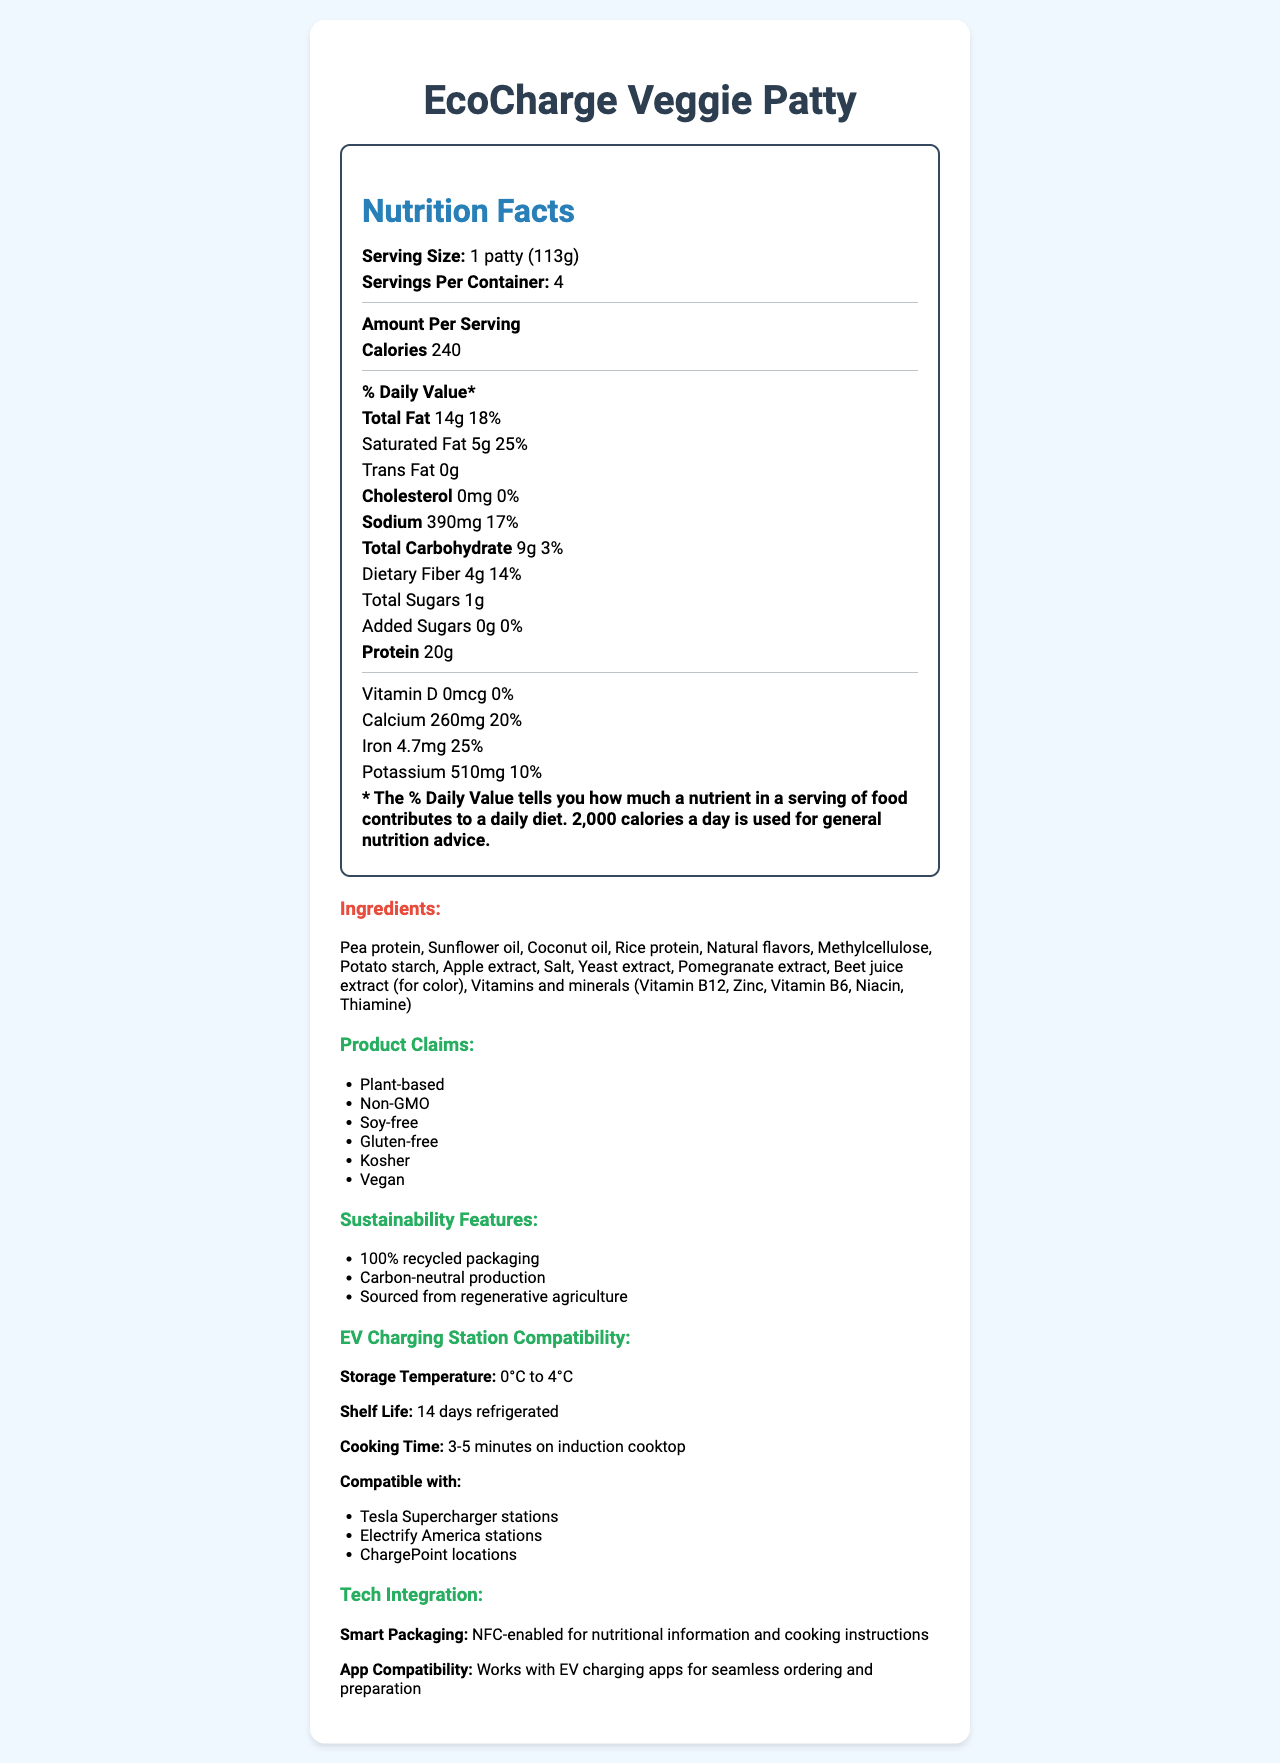what is the serving size? The document specifies the serving size under the "Nutrition Facts" section.
Answer: 1 patty (113g) how many calories are in one serving? The calories per serving are prominently displayed in the "Nutrition Facts" section.
Answer: 240 how many servings are in each container? The "Nutrition Facts" section lists "Servings Per Container" as 4.
Answer: 4 what is the amount of protein per serving? The amount of protein is clearly mentioned under the "Nutrition Facts" section.
Answer: 20g which claims are associated with this product? The claims are listed under the "Product Claims" section.
Answer: Plant-based, Non-GMO, Soy-free, Gluten-free, Kosher, Vegan the product contains which type of dietary fiber? A. Soluble B. Insoluble C. Both soluble and insoluble The type of dietary fiber is not specified in the document.
Answer: Cannot be determined how much sodium is in each serving, and what is the % daily value (%DV)? The "Nutrition Facts" section shows the sodium amount and %DV.
Answer: 390mg, 17% are there any added sugars in the product? The document lists "Added Sugars" as 0g and 0% daily value.
Answer: No is the product gluten-free? The product is listed as Gluten-free under the "Product Claims" section.
Answer: Yes what sustainability features does this product have? The sustainability features are listed in the "Sustainability Features" section.
Answer: 100% recycled packaging, Carbon-neutral production, Sourced from regenerative agriculture what is the storage temperature for the product at EV charging stations? The storage temperature is stated under the "EV Charging Station Compatibility" section.
Answer: 0°C to 4°C what are the main ingredients of the EcoCharge Veggie Patty? The ingredients are listed under the "Ingredients" section.
Answer: Pea protein, Sunflower oil, Coconut oil, Rice protein, Natural flavors, Methylcellulose, Potato starch, Apple extract, Salt, Yeast extract, Pomegranate extract, Beet juice extract, Vitamins and minerals which stations are compatible with this product? A. Tesla Supercharger stations B. Electrify America stations C. ChargePoint locations D. All of the above The document states compatibility with Tesla Supercharger stations, Electrify America stations, and ChargePoint locations under the "EV Charging Station Compatibility" section.
Answer: D. All of the above is the document about a meat-based product? The document is about a plant-based meat alternative, the EcoCharge Veggie Patty.
Answer: No describe the main features of the EcoCharge Veggie Patty product. The document details the nutrition facts, ingredients, claims, sustainability features, and technology integration of the EcoCharge Veggie Patty.
Answer: The EcoCharge Veggie Patty is a plant-based meat alternative with specific nutrition facts, including 14g total fat and 20g protein per serving. It claims to be Non-GMO, Soy-free, Gluten-free, Kosher, and Vegan. It has various sustainability features such as 100% recycled packaging and carbon-neutral production. It has specific compatibility with EV charging stations and integrates technology through NFC-enabled smart packaging and compatibility with EV charging apps. 